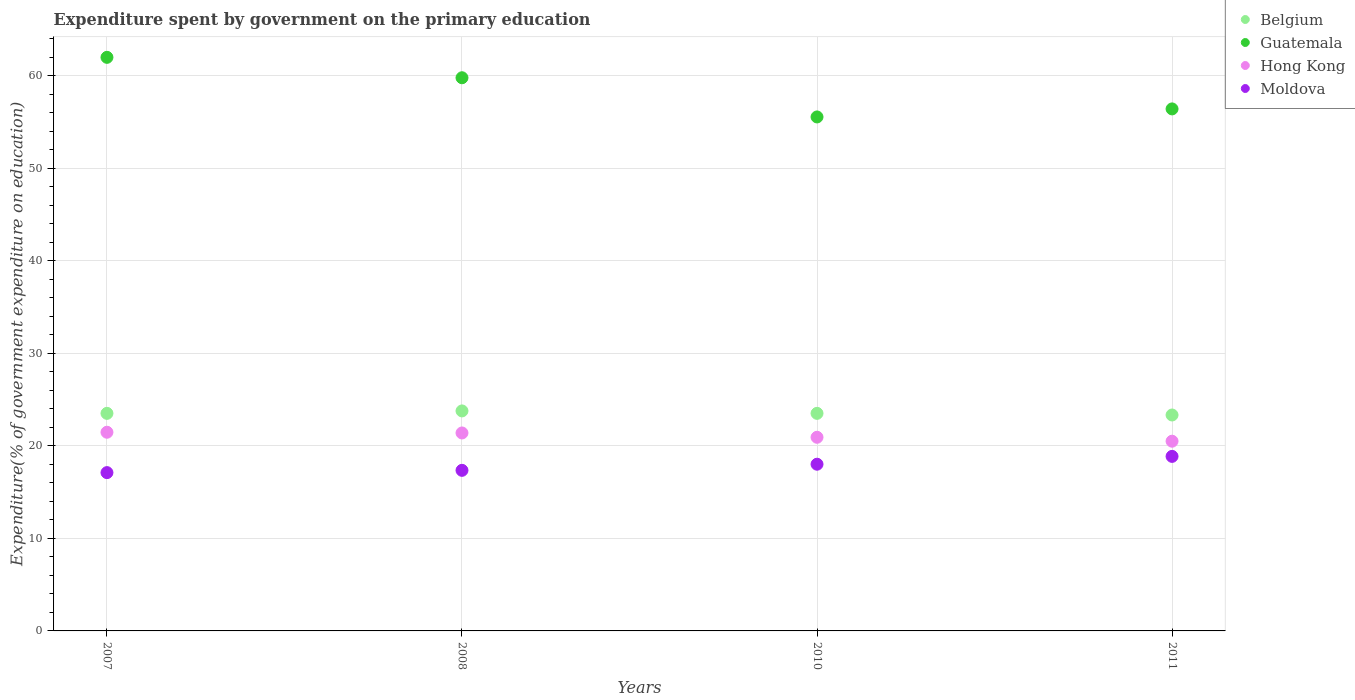How many different coloured dotlines are there?
Offer a terse response. 4. What is the expenditure spent by government on the primary education in Guatemala in 2007?
Keep it short and to the point. 62. Across all years, what is the maximum expenditure spent by government on the primary education in Hong Kong?
Make the answer very short. 21.47. Across all years, what is the minimum expenditure spent by government on the primary education in Moldova?
Your answer should be compact. 17.11. In which year was the expenditure spent by government on the primary education in Belgium minimum?
Provide a short and direct response. 2011. What is the total expenditure spent by government on the primary education in Hong Kong in the graph?
Provide a short and direct response. 84.31. What is the difference between the expenditure spent by government on the primary education in Belgium in 2008 and that in 2010?
Provide a short and direct response. 0.26. What is the difference between the expenditure spent by government on the primary education in Moldova in 2011 and the expenditure spent by government on the primary education in Belgium in 2007?
Offer a terse response. -4.65. What is the average expenditure spent by government on the primary education in Hong Kong per year?
Provide a succinct answer. 21.08. In the year 2010, what is the difference between the expenditure spent by government on the primary education in Hong Kong and expenditure spent by government on the primary education in Moldova?
Provide a short and direct response. 2.91. In how many years, is the expenditure spent by government on the primary education in Moldova greater than 36 %?
Give a very brief answer. 0. What is the ratio of the expenditure spent by government on the primary education in Moldova in 2007 to that in 2010?
Your answer should be very brief. 0.95. What is the difference between the highest and the second highest expenditure spent by government on the primary education in Guatemala?
Offer a terse response. 2.21. What is the difference between the highest and the lowest expenditure spent by government on the primary education in Guatemala?
Keep it short and to the point. 6.44. In how many years, is the expenditure spent by government on the primary education in Moldova greater than the average expenditure spent by government on the primary education in Moldova taken over all years?
Ensure brevity in your answer.  2. Is the sum of the expenditure spent by government on the primary education in Guatemala in 2008 and 2011 greater than the maximum expenditure spent by government on the primary education in Moldova across all years?
Provide a succinct answer. Yes. Is it the case that in every year, the sum of the expenditure spent by government on the primary education in Hong Kong and expenditure spent by government on the primary education in Moldova  is greater than the sum of expenditure spent by government on the primary education in Belgium and expenditure spent by government on the primary education in Guatemala?
Offer a terse response. Yes. Is it the case that in every year, the sum of the expenditure spent by government on the primary education in Hong Kong and expenditure spent by government on the primary education in Moldova  is greater than the expenditure spent by government on the primary education in Guatemala?
Give a very brief answer. No. How many years are there in the graph?
Provide a short and direct response. 4. What is the difference between two consecutive major ticks on the Y-axis?
Make the answer very short. 10. How are the legend labels stacked?
Your response must be concise. Vertical. What is the title of the graph?
Offer a terse response. Expenditure spent by government on the primary education. Does "Virgin Islands" appear as one of the legend labels in the graph?
Provide a short and direct response. No. What is the label or title of the Y-axis?
Provide a succinct answer. Expenditure(% of government expenditure on education). What is the Expenditure(% of government expenditure on education) in Belgium in 2007?
Give a very brief answer. 23.52. What is the Expenditure(% of government expenditure on education) in Guatemala in 2007?
Your response must be concise. 62. What is the Expenditure(% of government expenditure on education) in Hong Kong in 2007?
Your answer should be very brief. 21.47. What is the Expenditure(% of government expenditure on education) in Moldova in 2007?
Your response must be concise. 17.11. What is the Expenditure(% of government expenditure on education) of Belgium in 2008?
Your answer should be compact. 23.78. What is the Expenditure(% of government expenditure on education) of Guatemala in 2008?
Your answer should be compact. 59.79. What is the Expenditure(% of government expenditure on education) of Hong Kong in 2008?
Make the answer very short. 21.4. What is the Expenditure(% of government expenditure on education) of Moldova in 2008?
Offer a terse response. 17.36. What is the Expenditure(% of government expenditure on education) of Belgium in 2010?
Provide a short and direct response. 23.52. What is the Expenditure(% of government expenditure on education) of Guatemala in 2010?
Your response must be concise. 55.55. What is the Expenditure(% of government expenditure on education) of Hong Kong in 2010?
Provide a short and direct response. 20.93. What is the Expenditure(% of government expenditure on education) of Moldova in 2010?
Provide a short and direct response. 18.02. What is the Expenditure(% of government expenditure on education) of Belgium in 2011?
Provide a succinct answer. 23.34. What is the Expenditure(% of government expenditure on education) in Guatemala in 2011?
Your response must be concise. 56.42. What is the Expenditure(% of government expenditure on education) in Hong Kong in 2011?
Provide a succinct answer. 20.51. What is the Expenditure(% of government expenditure on education) in Moldova in 2011?
Offer a very short reply. 18.87. Across all years, what is the maximum Expenditure(% of government expenditure on education) in Belgium?
Ensure brevity in your answer.  23.78. Across all years, what is the maximum Expenditure(% of government expenditure on education) in Guatemala?
Keep it short and to the point. 62. Across all years, what is the maximum Expenditure(% of government expenditure on education) of Hong Kong?
Offer a terse response. 21.47. Across all years, what is the maximum Expenditure(% of government expenditure on education) in Moldova?
Your answer should be compact. 18.87. Across all years, what is the minimum Expenditure(% of government expenditure on education) of Belgium?
Keep it short and to the point. 23.34. Across all years, what is the minimum Expenditure(% of government expenditure on education) in Guatemala?
Your answer should be very brief. 55.55. Across all years, what is the minimum Expenditure(% of government expenditure on education) of Hong Kong?
Give a very brief answer. 20.51. Across all years, what is the minimum Expenditure(% of government expenditure on education) of Moldova?
Provide a short and direct response. 17.11. What is the total Expenditure(% of government expenditure on education) of Belgium in the graph?
Ensure brevity in your answer.  94.15. What is the total Expenditure(% of government expenditure on education) of Guatemala in the graph?
Offer a very short reply. 233.76. What is the total Expenditure(% of government expenditure on education) in Hong Kong in the graph?
Give a very brief answer. 84.31. What is the total Expenditure(% of government expenditure on education) in Moldova in the graph?
Ensure brevity in your answer.  71.35. What is the difference between the Expenditure(% of government expenditure on education) in Belgium in 2007 and that in 2008?
Provide a succinct answer. -0.26. What is the difference between the Expenditure(% of government expenditure on education) in Guatemala in 2007 and that in 2008?
Offer a very short reply. 2.21. What is the difference between the Expenditure(% of government expenditure on education) in Hong Kong in 2007 and that in 2008?
Keep it short and to the point. 0.08. What is the difference between the Expenditure(% of government expenditure on education) of Moldova in 2007 and that in 2008?
Make the answer very short. -0.25. What is the difference between the Expenditure(% of government expenditure on education) of Belgium in 2007 and that in 2010?
Your answer should be very brief. -0. What is the difference between the Expenditure(% of government expenditure on education) in Guatemala in 2007 and that in 2010?
Give a very brief answer. 6.44. What is the difference between the Expenditure(% of government expenditure on education) of Hong Kong in 2007 and that in 2010?
Provide a short and direct response. 0.54. What is the difference between the Expenditure(% of government expenditure on education) in Moldova in 2007 and that in 2010?
Your answer should be compact. -0.91. What is the difference between the Expenditure(% of government expenditure on education) in Belgium in 2007 and that in 2011?
Your answer should be compact. 0.18. What is the difference between the Expenditure(% of government expenditure on education) of Guatemala in 2007 and that in 2011?
Your answer should be compact. 5.57. What is the difference between the Expenditure(% of government expenditure on education) of Hong Kong in 2007 and that in 2011?
Keep it short and to the point. 0.97. What is the difference between the Expenditure(% of government expenditure on education) of Moldova in 2007 and that in 2011?
Offer a terse response. -1.75. What is the difference between the Expenditure(% of government expenditure on education) of Belgium in 2008 and that in 2010?
Make the answer very short. 0.26. What is the difference between the Expenditure(% of government expenditure on education) of Guatemala in 2008 and that in 2010?
Offer a very short reply. 4.24. What is the difference between the Expenditure(% of government expenditure on education) of Hong Kong in 2008 and that in 2010?
Provide a short and direct response. 0.47. What is the difference between the Expenditure(% of government expenditure on education) of Moldova in 2008 and that in 2010?
Keep it short and to the point. -0.66. What is the difference between the Expenditure(% of government expenditure on education) of Belgium in 2008 and that in 2011?
Your answer should be very brief. 0.44. What is the difference between the Expenditure(% of government expenditure on education) of Guatemala in 2008 and that in 2011?
Make the answer very short. 3.37. What is the difference between the Expenditure(% of government expenditure on education) in Hong Kong in 2008 and that in 2011?
Ensure brevity in your answer.  0.89. What is the difference between the Expenditure(% of government expenditure on education) in Moldova in 2008 and that in 2011?
Provide a short and direct response. -1.51. What is the difference between the Expenditure(% of government expenditure on education) in Belgium in 2010 and that in 2011?
Your answer should be compact. 0.18. What is the difference between the Expenditure(% of government expenditure on education) in Guatemala in 2010 and that in 2011?
Keep it short and to the point. -0.87. What is the difference between the Expenditure(% of government expenditure on education) of Hong Kong in 2010 and that in 2011?
Keep it short and to the point. 0.42. What is the difference between the Expenditure(% of government expenditure on education) of Moldova in 2010 and that in 2011?
Offer a very short reply. -0.85. What is the difference between the Expenditure(% of government expenditure on education) of Belgium in 2007 and the Expenditure(% of government expenditure on education) of Guatemala in 2008?
Give a very brief answer. -36.27. What is the difference between the Expenditure(% of government expenditure on education) in Belgium in 2007 and the Expenditure(% of government expenditure on education) in Hong Kong in 2008?
Keep it short and to the point. 2.12. What is the difference between the Expenditure(% of government expenditure on education) of Belgium in 2007 and the Expenditure(% of government expenditure on education) of Moldova in 2008?
Provide a succinct answer. 6.16. What is the difference between the Expenditure(% of government expenditure on education) in Guatemala in 2007 and the Expenditure(% of government expenditure on education) in Hong Kong in 2008?
Offer a terse response. 40.6. What is the difference between the Expenditure(% of government expenditure on education) of Guatemala in 2007 and the Expenditure(% of government expenditure on education) of Moldova in 2008?
Keep it short and to the point. 44.64. What is the difference between the Expenditure(% of government expenditure on education) in Hong Kong in 2007 and the Expenditure(% of government expenditure on education) in Moldova in 2008?
Offer a very short reply. 4.12. What is the difference between the Expenditure(% of government expenditure on education) in Belgium in 2007 and the Expenditure(% of government expenditure on education) in Guatemala in 2010?
Keep it short and to the point. -32.04. What is the difference between the Expenditure(% of government expenditure on education) of Belgium in 2007 and the Expenditure(% of government expenditure on education) of Hong Kong in 2010?
Your response must be concise. 2.59. What is the difference between the Expenditure(% of government expenditure on education) in Belgium in 2007 and the Expenditure(% of government expenditure on education) in Moldova in 2010?
Ensure brevity in your answer.  5.5. What is the difference between the Expenditure(% of government expenditure on education) in Guatemala in 2007 and the Expenditure(% of government expenditure on education) in Hong Kong in 2010?
Give a very brief answer. 41.07. What is the difference between the Expenditure(% of government expenditure on education) of Guatemala in 2007 and the Expenditure(% of government expenditure on education) of Moldova in 2010?
Your answer should be very brief. 43.98. What is the difference between the Expenditure(% of government expenditure on education) of Hong Kong in 2007 and the Expenditure(% of government expenditure on education) of Moldova in 2010?
Your response must be concise. 3.46. What is the difference between the Expenditure(% of government expenditure on education) in Belgium in 2007 and the Expenditure(% of government expenditure on education) in Guatemala in 2011?
Offer a terse response. -32.91. What is the difference between the Expenditure(% of government expenditure on education) of Belgium in 2007 and the Expenditure(% of government expenditure on education) of Hong Kong in 2011?
Make the answer very short. 3.01. What is the difference between the Expenditure(% of government expenditure on education) of Belgium in 2007 and the Expenditure(% of government expenditure on education) of Moldova in 2011?
Your answer should be compact. 4.65. What is the difference between the Expenditure(% of government expenditure on education) of Guatemala in 2007 and the Expenditure(% of government expenditure on education) of Hong Kong in 2011?
Provide a succinct answer. 41.49. What is the difference between the Expenditure(% of government expenditure on education) in Guatemala in 2007 and the Expenditure(% of government expenditure on education) in Moldova in 2011?
Make the answer very short. 43.13. What is the difference between the Expenditure(% of government expenditure on education) of Hong Kong in 2007 and the Expenditure(% of government expenditure on education) of Moldova in 2011?
Make the answer very short. 2.61. What is the difference between the Expenditure(% of government expenditure on education) of Belgium in 2008 and the Expenditure(% of government expenditure on education) of Guatemala in 2010?
Make the answer very short. -31.78. What is the difference between the Expenditure(% of government expenditure on education) of Belgium in 2008 and the Expenditure(% of government expenditure on education) of Hong Kong in 2010?
Keep it short and to the point. 2.85. What is the difference between the Expenditure(% of government expenditure on education) in Belgium in 2008 and the Expenditure(% of government expenditure on education) in Moldova in 2010?
Your answer should be compact. 5.76. What is the difference between the Expenditure(% of government expenditure on education) of Guatemala in 2008 and the Expenditure(% of government expenditure on education) of Hong Kong in 2010?
Ensure brevity in your answer.  38.86. What is the difference between the Expenditure(% of government expenditure on education) of Guatemala in 2008 and the Expenditure(% of government expenditure on education) of Moldova in 2010?
Provide a succinct answer. 41.77. What is the difference between the Expenditure(% of government expenditure on education) of Hong Kong in 2008 and the Expenditure(% of government expenditure on education) of Moldova in 2010?
Offer a very short reply. 3.38. What is the difference between the Expenditure(% of government expenditure on education) of Belgium in 2008 and the Expenditure(% of government expenditure on education) of Guatemala in 2011?
Your answer should be very brief. -32.64. What is the difference between the Expenditure(% of government expenditure on education) of Belgium in 2008 and the Expenditure(% of government expenditure on education) of Hong Kong in 2011?
Offer a terse response. 3.27. What is the difference between the Expenditure(% of government expenditure on education) in Belgium in 2008 and the Expenditure(% of government expenditure on education) in Moldova in 2011?
Offer a very short reply. 4.91. What is the difference between the Expenditure(% of government expenditure on education) in Guatemala in 2008 and the Expenditure(% of government expenditure on education) in Hong Kong in 2011?
Ensure brevity in your answer.  39.28. What is the difference between the Expenditure(% of government expenditure on education) of Guatemala in 2008 and the Expenditure(% of government expenditure on education) of Moldova in 2011?
Offer a terse response. 40.92. What is the difference between the Expenditure(% of government expenditure on education) in Hong Kong in 2008 and the Expenditure(% of government expenditure on education) in Moldova in 2011?
Provide a succinct answer. 2.53. What is the difference between the Expenditure(% of government expenditure on education) of Belgium in 2010 and the Expenditure(% of government expenditure on education) of Guatemala in 2011?
Provide a succinct answer. -32.91. What is the difference between the Expenditure(% of government expenditure on education) of Belgium in 2010 and the Expenditure(% of government expenditure on education) of Hong Kong in 2011?
Keep it short and to the point. 3.01. What is the difference between the Expenditure(% of government expenditure on education) in Belgium in 2010 and the Expenditure(% of government expenditure on education) in Moldova in 2011?
Your answer should be compact. 4.65. What is the difference between the Expenditure(% of government expenditure on education) of Guatemala in 2010 and the Expenditure(% of government expenditure on education) of Hong Kong in 2011?
Offer a terse response. 35.05. What is the difference between the Expenditure(% of government expenditure on education) of Guatemala in 2010 and the Expenditure(% of government expenditure on education) of Moldova in 2011?
Your answer should be very brief. 36.69. What is the difference between the Expenditure(% of government expenditure on education) in Hong Kong in 2010 and the Expenditure(% of government expenditure on education) in Moldova in 2011?
Make the answer very short. 2.07. What is the average Expenditure(% of government expenditure on education) in Belgium per year?
Ensure brevity in your answer.  23.54. What is the average Expenditure(% of government expenditure on education) in Guatemala per year?
Your response must be concise. 58.44. What is the average Expenditure(% of government expenditure on education) in Hong Kong per year?
Ensure brevity in your answer.  21.08. What is the average Expenditure(% of government expenditure on education) of Moldova per year?
Provide a succinct answer. 17.84. In the year 2007, what is the difference between the Expenditure(% of government expenditure on education) in Belgium and Expenditure(% of government expenditure on education) in Guatemala?
Ensure brevity in your answer.  -38.48. In the year 2007, what is the difference between the Expenditure(% of government expenditure on education) of Belgium and Expenditure(% of government expenditure on education) of Hong Kong?
Provide a short and direct response. 2.04. In the year 2007, what is the difference between the Expenditure(% of government expenditure on education) in Belgium and Expenditure(% of government expenditure on education) in Moldova?
Your answer should be compact. 6.41. In the year 2007, what is the difference between the Expenditure(% of government expenditure on education) of Guatemala and Expenditure(% of government expenditure on education) of Hong Kong?
Keep it short and to the point. 40.52. In the year 2007, what is the difference between the Expenditure(% of government expenditure on education) in Guatemala and Expenditure(% of government expenditure on education) in Moldova?
Your answer should be compact. 44.89. In the year 2007, what is the difference between the Expenditure(% of government expenditure on education) of Hong Kong and Expenditure(% of government expenditure on education) of Moldova?
Ensure brevity in your answer.  4.36. In the year 2008, what is the difference between the Expenditure(% of government expenditure on education) of Belgium and Expenditure(% of government expenditure on education) of Guatemala?
Your answer should be very brief. -36.01. In the year 2008, what is the difference between the Expenditure(% of government expenditure on education) of Belgium and Expenditure(% of government expenditure on education) of Hong Kong?
Ensure brevity in your answer.  2.38. In the year 2008, what is the difference between the Expenditure(% of government expenditure on education) in Belgium and Expenditure(% of government expenditure on education) in Moldova?
Keep it short and to the point. 6.42. In the year 2008, what is the difference between the Expenditure(% of government expenditure on education) of Guatemala and Expenditure(% of government expenditure on education) of Hong Kong?
Give a very brief answer. 38.39. In the year 2008, what is the difference between the Expenditure(% of government expenditure on education) in Guatemala and Expenditure(% of government expenditure on education) in Moldova?
Provide a succinct answer. 42.43. In the year 2008, what is the difference between the Expenditure(% of government expenditure on education) in Hong Kong and Expenditure(% of government expenditure on education) in Moldova?
Your response must be concise. 4.04. In the year 2010, what is the difference between the Expenditure(% of government expenditure on education) of Belgium and Expenditure(% of government expenditure on education) of Guatemala?
Your answer should be compact. -32.04. In the year 2010, what is the difference between the Expenditure(% of government expenditure on education) in Belgium and Expenditure(% of government expenditure on education) in Hong Kong?
Your answer should be very brief. 2.59. In the year 2010, what is the difference between the Expenditure(% of government expenditure on education) in Belgium and Expenditure(% of government expenditure on education) in Moldova?
Offer a terse response. 5.5. In the year 2010, what is the difference between the Expenditure(% of government expenditure on education) in Guatemala and Expenditure(% of government expenditure on education) in Hong Kong?
Ensure brevity in your answer.  34.62. In the year 2010, what is the difference between the Expenditure(% of government expenditure on education) in Guatemala and Expenditure(% of government expenditure on education) in Moldova?
Your answer should be very brief. 37.54. In the year 2010, what is the difference between the Expenditure(% of government expenditure on education) of Hong Kong and Expenditure(% of government expenditure on education) of Moldova?
Give a very brief answer. 2.91. In the year 2011, what is the difference between the Expenditure(% of government expenditure on education) of Belgium and Expenditure(% of government expenditure on education) of Guatemala?
Provide a short and direct response. -33.08. In the year 2011, what is the difference between the Expenditure(% of government expenditure on education) of Belgium and Expenditure(% of government expenditure on education) of Hong Kong?
Your answer should be compact. 2.83. In the year 2011, what is the difference between the Expenditure(% of government expenditure on education) of Belgium and Expenditure(% of government expenditure on education) of Moldova?
Your answer should be compact. 4.47. In the year 2011, what is the difference between the Expenditure(% of government expenditure on education) in Guatemala and Expenditure(% of government expenditure on education) in Hong Kong?
Make the answer very short. 35.92. In the year 2011, what is the difference between the Expenditure(% of government expenditure on education) in Guatemala and Expenditure(% of government expenditure on education) in Moldova?
Offer a terse response. 37.56. In the year 2011, what is the difference between the Expenditure(% of government expenditure on education) of Hong Kong and Expenditure(% of government expenditure on education) of Moldova?
Your answer should be very brief. 1.64. What is the ratio of the Expenditure(% of government expenditure on education) of Guatemala in 2007 to that in 2008?
Ensure brevity in your answer.  1.04. What is the ratio of the Expenditure(% of government expenditure on education) in Moldova in 2007 to that in 2008?
Ensure brevity in your answer.  0.99. What is the ratio of the Expenditure(% of government expenditure on education) of Guatemala in 2007 to that in 2010?
Keep it short and to the point. 1.12. What is the ratio of the Expenditure(% of government expenditure on education) of Hong Kong in 2007 to that in 2010?
Provide a succinct answer. 1.03. What is the ratio of the Expenditure(% of government expenditure on education) in Moldova in 2007 to that in 2010?
Give a very brief answer. 0.95. What is the ratio of the Expenditure(% of government expenditure on education) of Belgium in 2007 to that in 2011?
Your answer should be very brief. 1.01. What is the ratio of the Expenditure(% of government expenditure on education) in Guatemala in 2007 to that in 2011?
Provide a short and direct response. 1.1. What is the ratio of the Expenditure(% of government expenditure on education) of Hong Kong in 2007 to that in 2011?
Ensure brevity in your answer.  1.05. What is the ratio of the Expenditure(% of government expenditure on education) in Moldova in 2007 to that in 2011?
Provide a succinct answer. 0.91. What is the ratio of the Expenditure(% of government expenditure on education) of Belgium in 2008 to that in 2010?
Offer a very short reply. 1.01. What is the ratio of the Expenditure(% of government expenditure on education) of Guatemala in 2008 to that in 2010?
Offer a terse response. 1.08. What is the ratio of the Expenditure(% of government expenditure on education) in Hong Kong in 2008 to that in 2010?
Keep it short and to the point. 1.02. What is the ratio of the Expenditure(% of government expenditure on education) in Moldova in 2008 to that in 2010?
Your response must be concise. 0.96. What is the ratio of the Expenditure(% of government expenditure on education) in Belgium in 2008 to that in 2011?
Provide a short and direct response. 1.02. What is the ratio of the Expenditure(% of government expenditure on education) in Guatemala in 2008 to that in 2011?
Provide a succinct answer. 1.06. What is the ratio of the Expenditure(% of government expenditure on education) in Hong Kong in 2008 to that in 2011?
Provide a succinct answer. 1.04. What is the ratio of the Expenditure(% of government expenditure on education) in Moldova in 2008 to that in 2011?
Provide a succinct answer. 0.92. What is the ratio of the Expenditure(% of government expenditure on education) in Belgium in 2010 to that in 2011?
Give a very brief answer. 1.01. What is the ratio of the Expenditure(% of government expenditure on education) of Guatemala in 2010 to that in 2011?
Provide a short and direct response. 0.98. What is the ratio of the Expenditure(% of government expenditure on education) of Hong Kong in 2010 to that in 2011?
Offer a very short reply. 1.02. What is the ratio of the Expenditure(% of government expenditure on education) of Moldova in 2010 to that in 2011?
Your answer should be very brief. 0.96. What is the difference between the highest and the second highest Expenditure(% of government expenditure on education) in Belgium?
Your answer should be compact. 0.26. What is the difference between the highest and the second highest Expenditure(% of government expenditure on education) of Guatemala?
Offer a very short reply. 2.21. What is the difference between the highest and the second highest Expenditure(% of government expenditure on education) of Hong Kong?
Provide a short and direct response. 0.08. What is the difference between the highest and the second highest Expenditure(% of government expenditure on education) of Moldova?
Give a very brief answer. 0.85. What is the difference between the highest and the lowest Expenditure(% of government expenditure on education) in Belgium?
Offer a terse response. 0.44. What is the difference between the highest and the lowest Expenditure(% of government expenditure on education) in Guatemala?
Make the answer very short. 6.44. What is the difference between the highest and the lowest Expenditure(% of government expenditure on education) of Hong Kong?
Offer a very short reply. 0.97. What is the difference between the highest and the lowest Expenditure(% of government expenditure on education) in Moldova?
Your response must be concise. 1.75. 